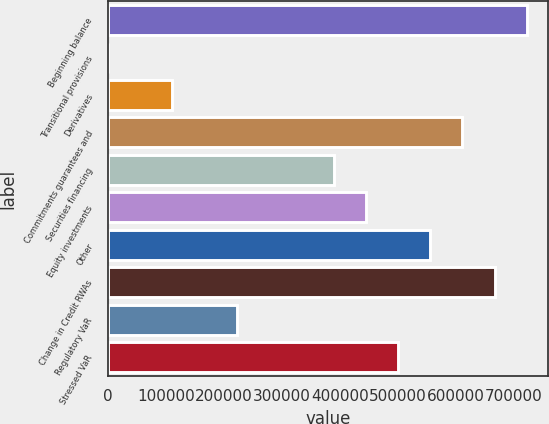Convert chart. <chart><loc_0><loc_0><loc_500><loc_500><bar_chart><fcel>Beginning balance<fcel>Transitional provisions<fcel>Derivatives<fcel>Commitments guarantees and<fcel>Securities financing<fcel>Equity investments<fcel>Other<fcel>Change in Credit RWAs<fcel>Regulatory VaR<fcel>Stressed VaR<nl><fcel>722224<fcel>233<fcel>111309<fcel>611149<fcel>388998<fcel>444535<fcel>555611<fcel>666687<fcel>222384<fcel>500073<nl></chart> 